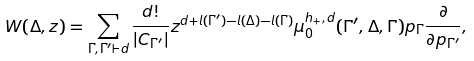<formula> <loc_0><loc_0><loc_500><loc_500>W ( \Delta , z ) = \sum _ { \Gamma , \Gamma ^ { \prime } \vdash d } \frac { d ! } { | C _ { \Gamma ^ { \prime } } | } z ^ { d + l ( \Gamma ^ { \prime } ) - l ( \Delta ) - l ( \Gamma ) } \mu _ { 0 } ^ { h _ { + } , d } ( \Gamma ^ { \prime } , \Delta , \Gamma ) p _ { \Gamma } \frac { \partial } { \partial p _ { \Gamma ^ { \prime } } } ,</formula> 